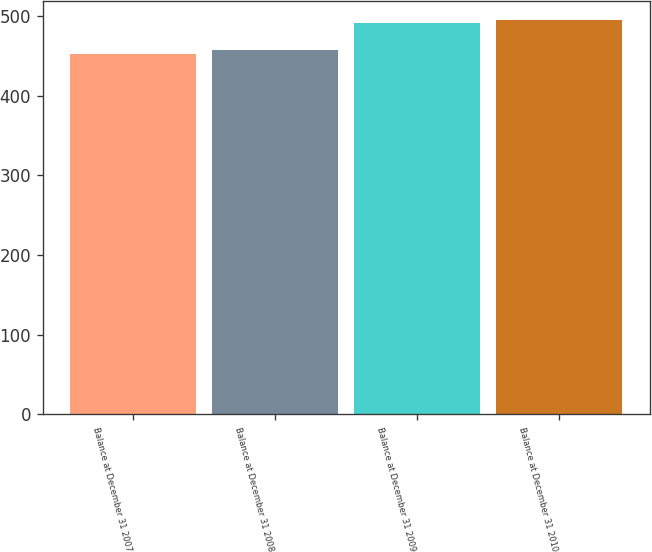Convert chart. <chart><loc_0><loc_0><loc_500><loc_500><bar_chart><fcel>Balance at December 31 2007<fcel>Balance at December 31 2008<fcel>Balance at December 31 2009<fcel>Balance at December 31 2010<nl><fcel>453<fcel>457<fcel>491<fcel>495<nl></chart> 